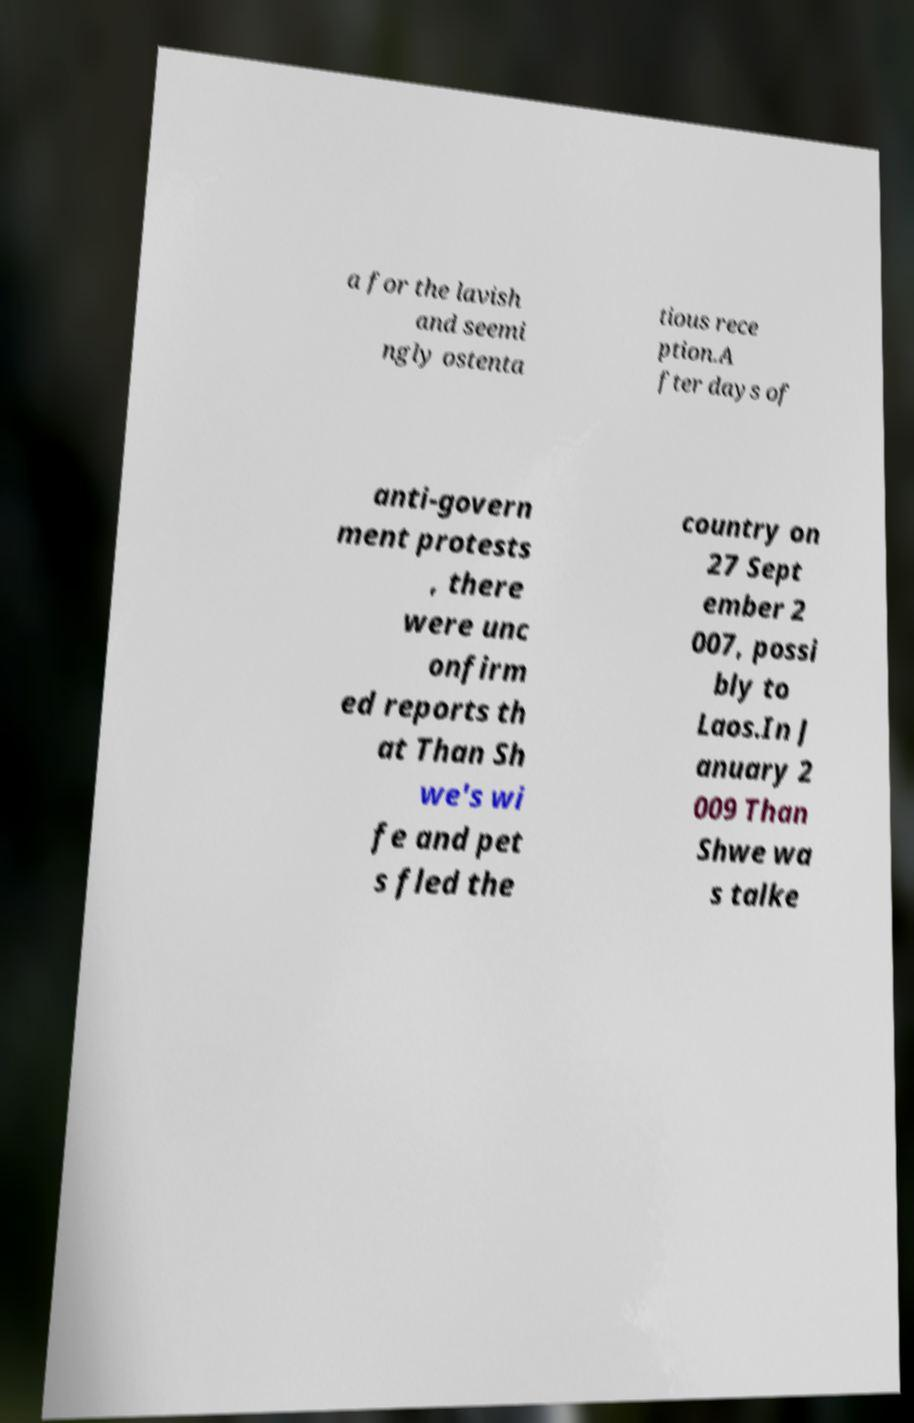What messages or text are displayed in this image? I need them in a readable, typed format. a for the lavish and seemi ngly ostenta tious rece ption.A fter days of anti-govern ment protests , there were unc onfirm ed reports th at Than Sh we's wi fe and pet s fled the country on 27 Sept ember 2 007, possi bly to Laos.In J anuary 2 009 Than Shwe wa s talke 